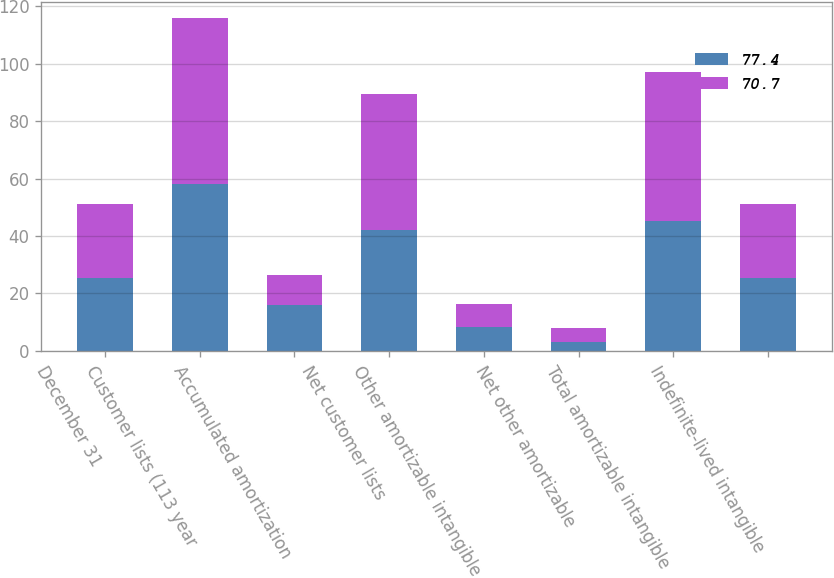Convert chart to OTSL. <chart><loc_0><loc_0><loc_500><loc_500><stacked_bar_chart><ecel><fcel>December 31<fcel>Customer lists (113 year<fcel>Accumulated amortization<fcel>Net customer lists<fcel>Other amortizable intangible<fcel>Net other amortizable<fcel>Total amortizable intangible<fcel>Indefinite-lived intangible<nl><fcel>77.4<fcel>25.5<fcel>58<fcel>15.9<fcel>42.1<fcel>8.2<fcel>3.1<fcel>45.2<fcel>25.5<nl><fcel>70.7<fcel>25.5<fcel>57.8<fcel>10.6<fcel>47.2<fcel>8.2<fcel>4.7<fcel>51.9<fcel>25.5<nl></chart> 